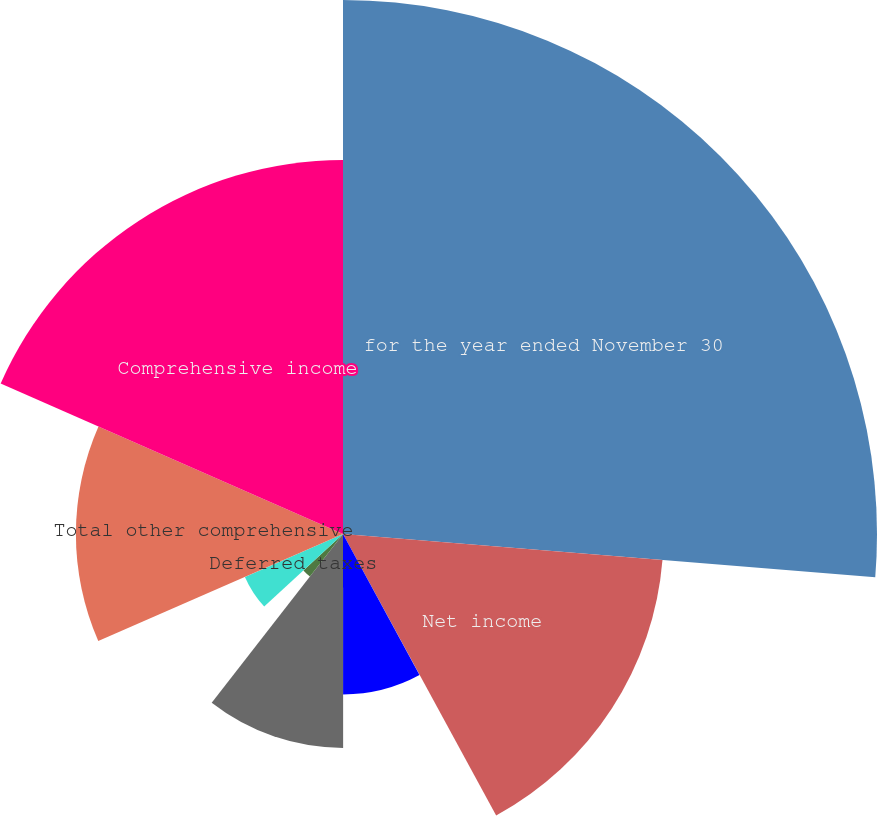Convert chart. <chart><loc_0><loc_0><loc_500><loc_500><pie_chart><fcel>for the year ended November 30<fcel>Net income<fcel>Net income (loss) attributable<fcel>Unrealized components of<fcel>Currency translation<fcel>Change in derivative financial<fcel>Deferred taxes<fcel>Total other comprehensive<fcel>Comprehensive income<nl><fcel>26.29%<fcel>15.78%<fcel>0.02%<fcel>7.9%<fcel>10.53%<fcel>2.65%<fcel>5.27%<fcel>13.15%<fcel>18.41%<nl></chart> 